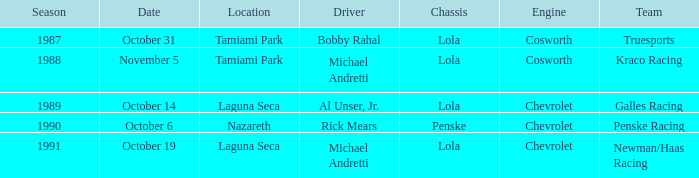What engine does Galles Racing use? Chevrolet. 